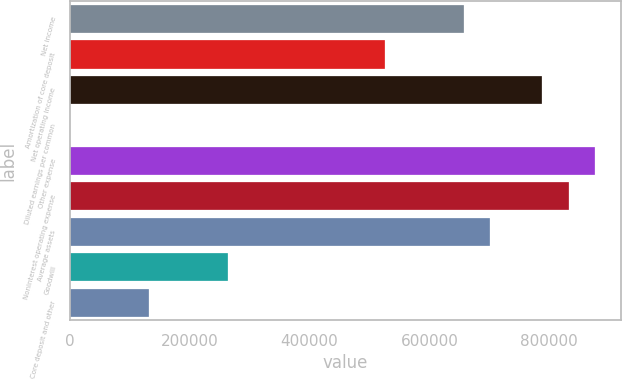Convert chart. <chart><loc_0><loc_0><loc_500><loc_500><bar_chart><fcel>Net income<fcel>Amortization of core deposit<fcel>Net operating income<fcel>Diluted earnings per common<fcel>Other expense<fcel>Noninterest operating expense<fcel>Average assets<fcel>Goodwill<fcel>Core deposit and other<nl><fcel>657519<fcel>526015<fcel>789022<fcel>0.49<fcel>876691<fcel>832857<fcel>701353<fcel>263008<fcel>131504<nl></chart> 